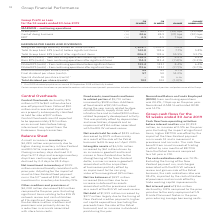According to Woolworths Limited's financial document, What is the value of Central Overheads in F19? According to the financial document, $60 million. The relevant text states: "entral Overheads declined by $76 million in F19 to $60 million due to a one‑off payment from Caltex of $50 million and a reversal of impairment on a property subse..." Also, What is the total dividend per share in F19? According to the financial document, 102. The relevant text states: "nts) 1 – 10 n.m. Total dividend per share (cents) 102 103 (1.0)%..." Also, What is the EBIT for F19? According to the financial document, 4.5 (percentage). The relevant text states: "business (%) 24.6 24.9 (31) bps (30) bps EBIT (%) 4.5 4.5 7 bps 7 bps..." Also, can you calculate: What percentage of the total dividend per share does the interim dividend per share constitute? Based on the calculation: 45/102 , the result is 44.12 (percentage). This is based on the information: "(7.7)% (9.7)% Interim dividend per share (cents) 45 43 4.7% Final dividend per share (cents) 1 57 50 14.0% Special dividend per share (cents) 1 – 10 n. nts) 1 – 10 n.m. Total dividend per share (cents..." The key data points involved are: 102, 45. Also, can you calculate: What is the nominal difference of the total group basic EPS (cents) before significant items and after significant items? Based on the calculation: 206.2-142.8 , the result is 63.4. This is based on the information: "Group basic EPS (cents) before significant items 142.8 132.6 7.7% 5.8% Total Group basic EPS (cents) after significant items 206.2 132.6 55.5% 53.7% Basic l Group basic EPS (cents) after significant i..." The key data points involved are: 142.8, 206.2. Also, can you calculate: What is the value of Central Overheads in F18? Based on the calculation: 76 + 60 , the result is 136 (in millions). This is based on the information: "tral Overheads declined by $76 million in F19 to $60 million due to a one‑off payment from Caltex of $50 million and a reversal of impairment on a prope Central Overheads declined by $76 million in F1..." The key data points involved are: 60, 76. 